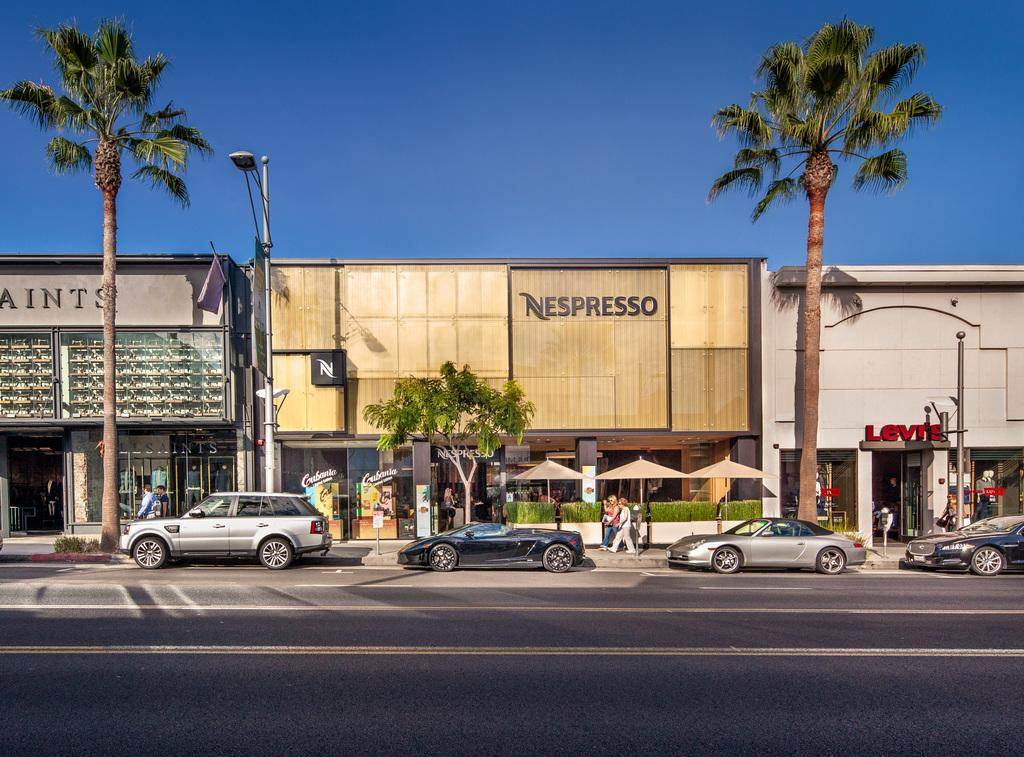What type of establishments can be seen in the image? There are stores in the image. What natural elements are present in the image? There are trees in the image. What type of lighting is present in the image? There is a streetlight in the image. What type of vehicles can be seen in the image? There are cars on the road in the image. What activity are people engaged in within the image? There are people walking in the image. What is visible at the top of the image? The sky is visible at the top of the image. Can you hear the whistle of a soldier in the image? There is no whistle or soldier present in the image. What type of sorting is happening in the image? There is no sorting activity depicted in the image. 